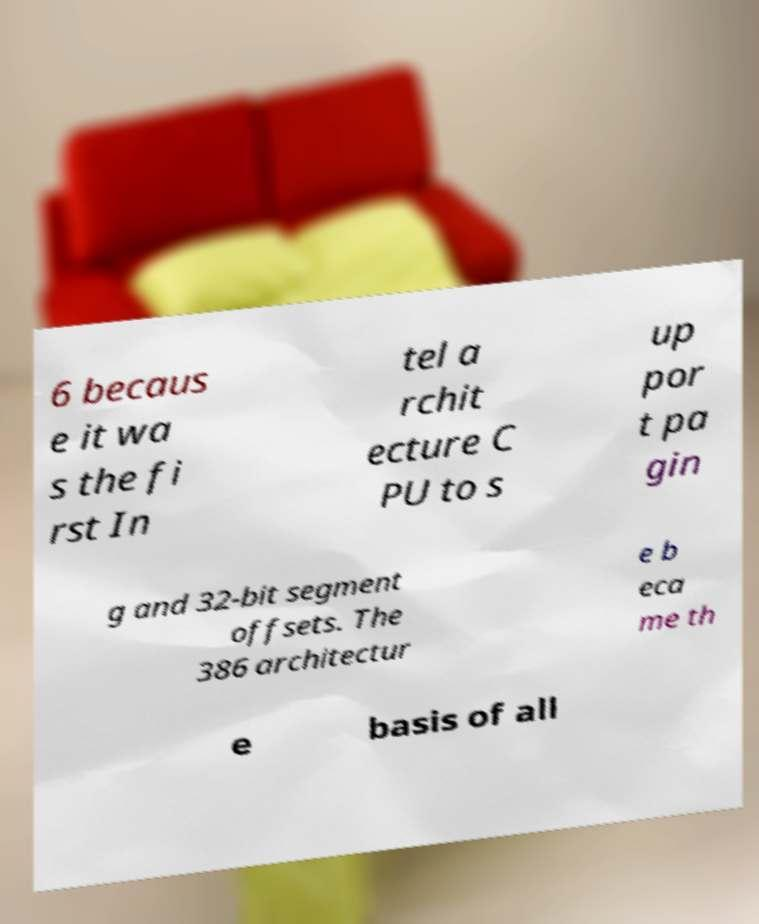Please read and relay the text visible in this image. What does it say? 6 becaus e it wa s the fi rst In tel a rchit ecture C PU to s up por t pa gin g and 32-bit segment offsets. The 386 architectur e b eca me th e basis of all 